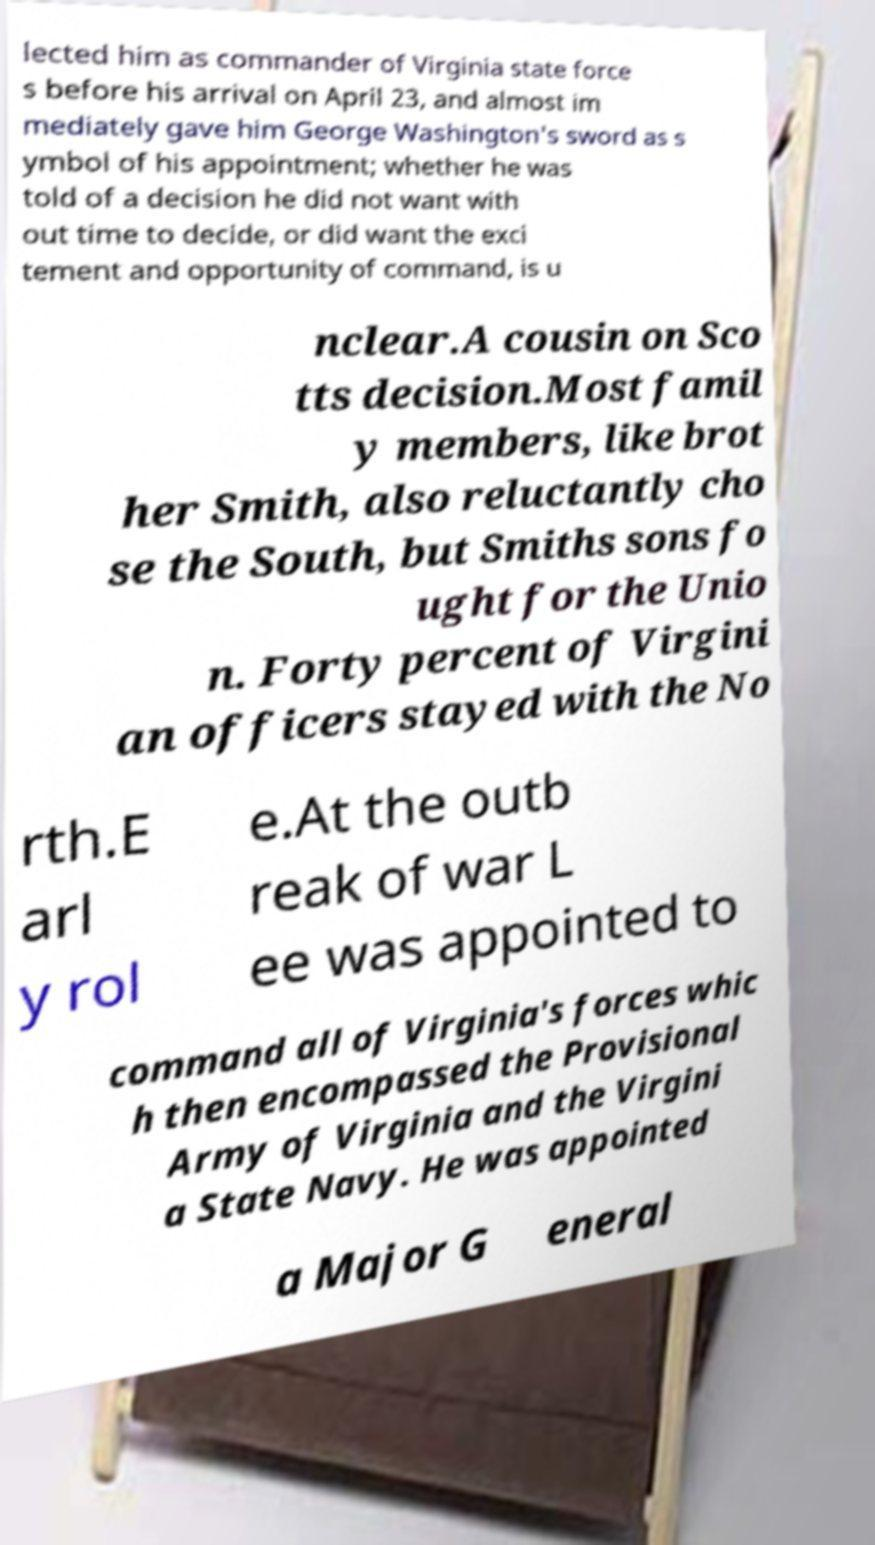Can you accurately transcribe the text from the provided image for me? lected him as commander of Virginia state force s before his arrival on April 23, and almost im mediately gave him George Washington's sword as s ymbol of his appointment; whether he was told of a decision he did not want with out time to decide, or did want the exci tement and opportunity of command, is u nclear.A cousin on Sco tts decision.Most famil y members, like brot her Smith, also reluctantly cho se the South, but Smiths sons fo ught for the Unio n. Forty percent of Virgini an officers stayed with the No rth.E arl y rol e.At the outb reak of war L ee was appointed to command all of Virginia's forces whic h then encompassed the Provisional Army of Virginia and the Virgini a State Navy. He was appointed a Major G eneral 